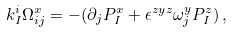<formula> <loc_0><loc_0><loc_500><loc_500>k ^ { i } _ { I } \Omega ^ { x } _ { i j } = - ( \partial _ { j } P ^ { x } _ { I } + \epsilon ^ { z y z } \omega ^ { y } _ { j } P ^ { z } _ { I } ) \, ,</formula> 